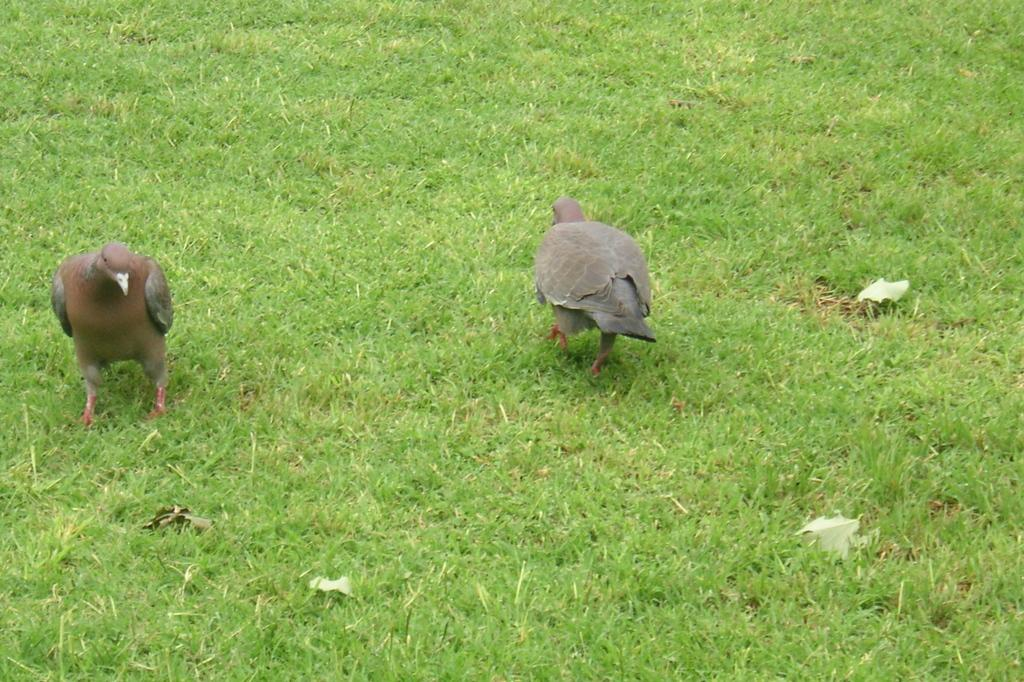How many birds are present in the image? There are two birds in the image. Where are the birds located? The birds are on the grass. What type of environment might the image depict? The image may have been taken in a park, given the presence of grass. What type of chalk is the bird holding in the image? There is no chalk present in the image, and the birds are not holding anything. 